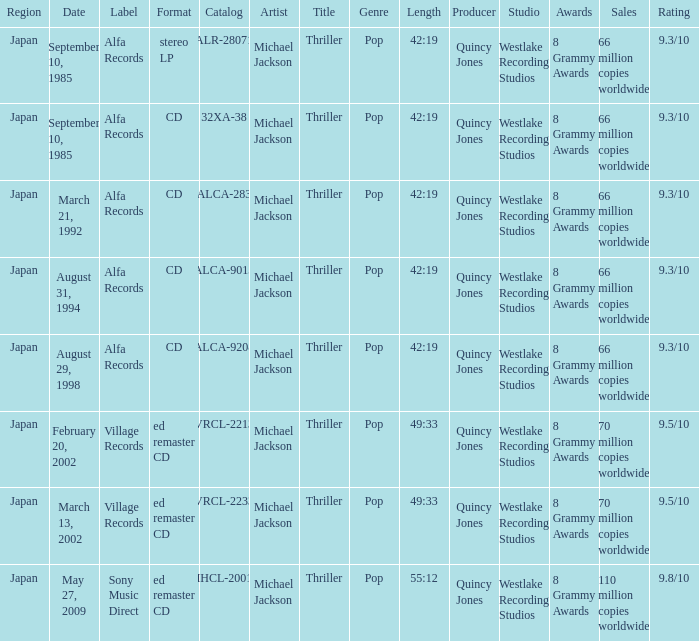Which marking was documented as alca-9013? Alfa Records. 